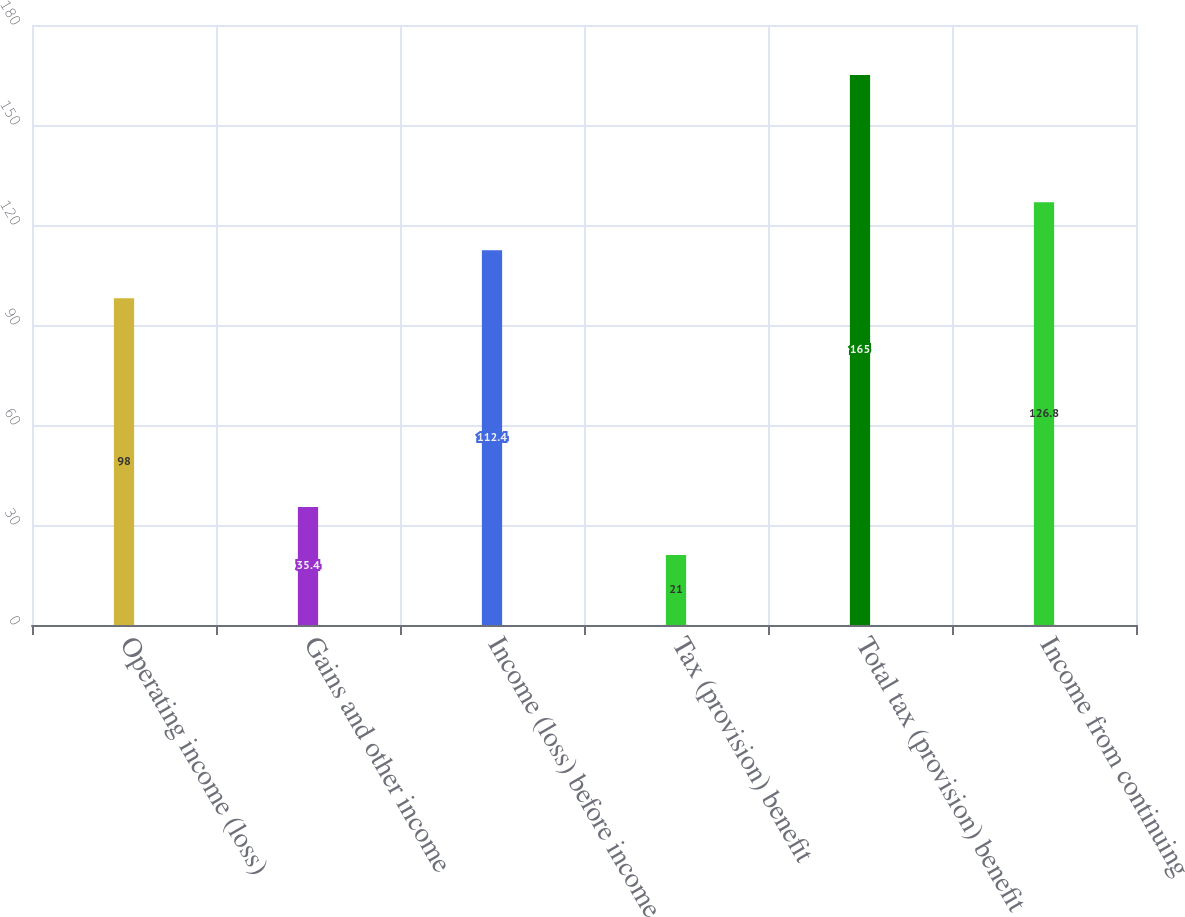<chart> <loc_0><loc_0><loc_500><loc_500><bar_chart><fcel>Operating income (loss)<fcel>Gains and other income<fcel>Income (loss) before income<fcel>Tax (provision) benefit<fcel>Total tax (provision) benefit<fcel>Income from continuing<nl><fcel>98<fcel>35.4<fcel>112.4<fcel>21<fcel>165<fcel>126.8<nl></chart> 